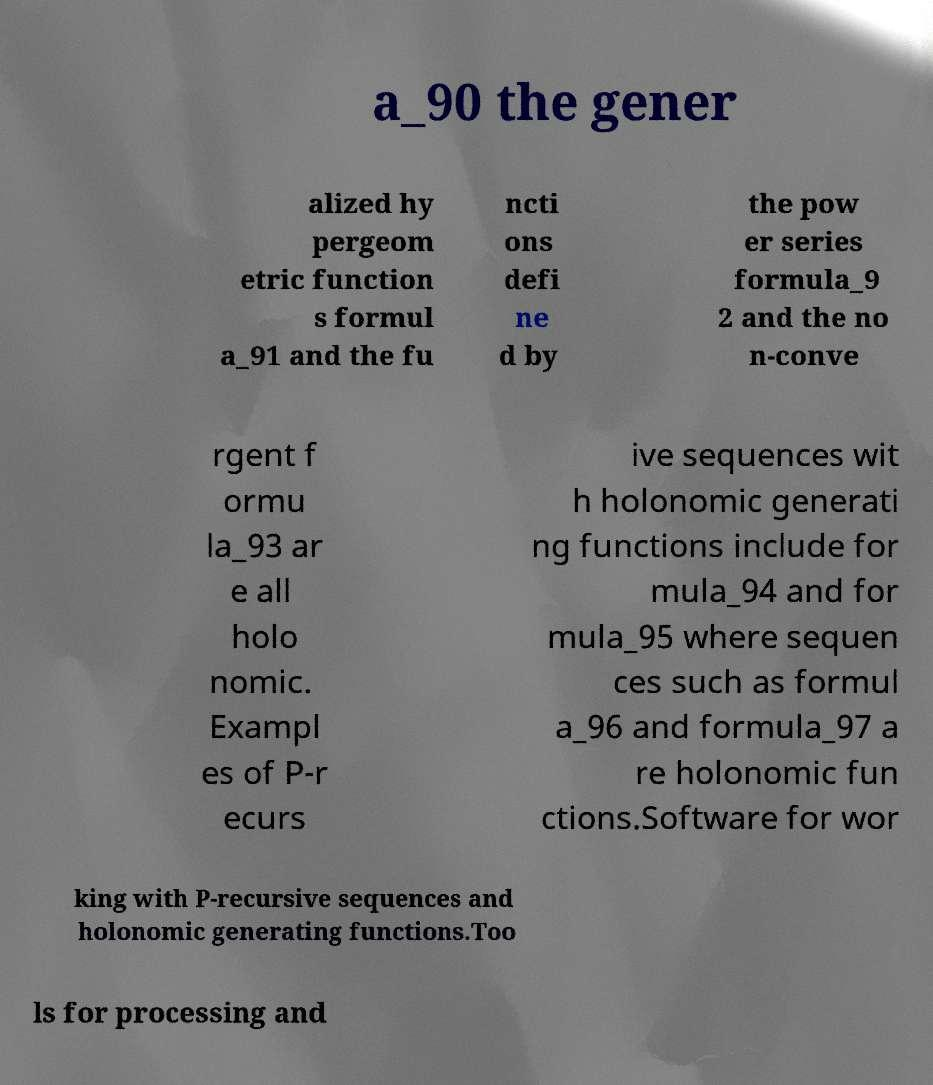Can you accurately transcribe the text from the provided image for me? a_90 the gener alized hy pergeom etric function s formul a_91 and the fu ncti ons defi ne d by the pow er series formula_9 2 and the no n-conve rgent f ormu la_93 ar e all holo nomic. Exampl es of P-r ecurs ive sequences wit h holonomic generati ng functions include for mula_94 and for mula_95 where sequen ces such as formul a_96 and formula_97 a re holonomic fun ctions.Software for wor king with P-recursive sequences and holonomic generating functions.Too ls for processing and 